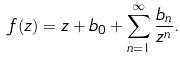Convert formula to latex. <formula><loc_0><loc_0><loc_500><loc_500>f ( z ) = z + b _ { 0 } + \sum _ { n = 1 } ^ { \infty } \frac { b _ { n } } { z ^ { n } } .</formula> 